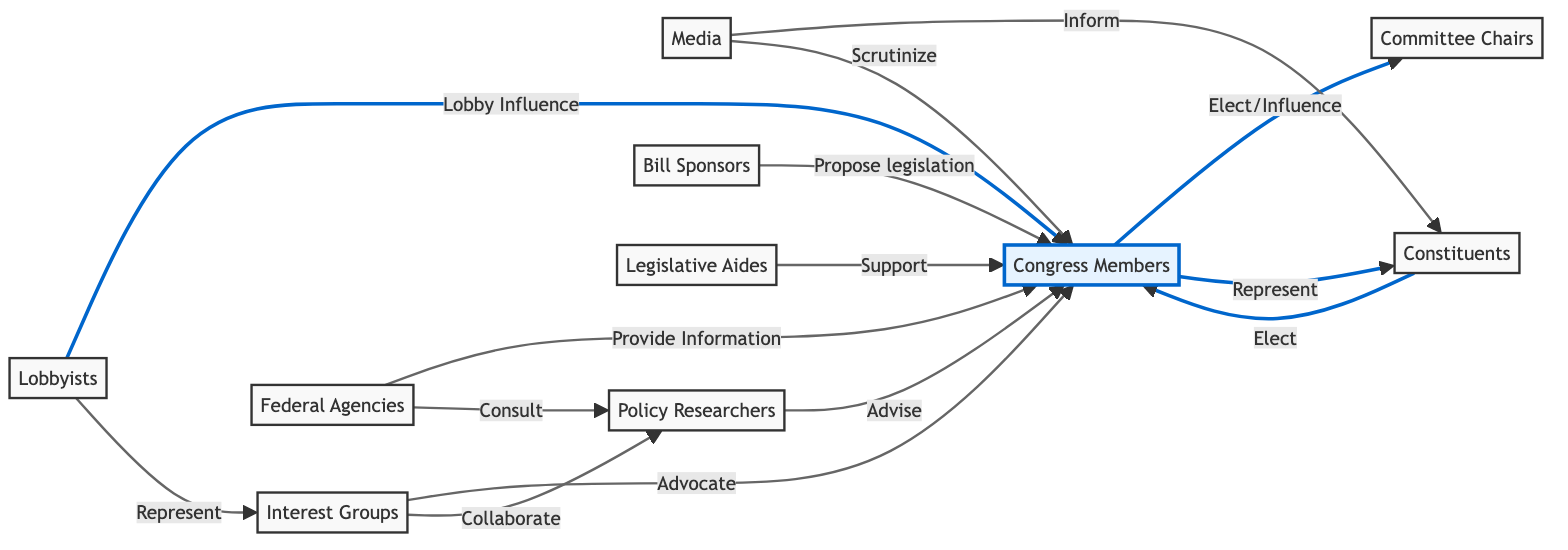What is the total number of nodes in the diagram? The diagram contains 10 nodes, which can be counted directly from the nodes section of the data.
Answer: 10 Which node represents the group that proposes legislation? The node "Bill Sponsors" directly indicates the entity that proposes legislation, as seen in the edges linking "Bill Sponsors" to "Congress Members" with the label "Propose legislation."
Answer: Bill Sponsors How do constituents influence Congress members? Constituents influence Congress members by electing them, as indicated by the directed edge labeled "Elect" from "Constituents" to "Congress Members."
Answer: Elect Which node is connected to "Congress Members" by providing information? "Federal Agencies" is connected to "Congress Members" with the edge labeled "Provide Information," indicating the flow of information from this stakeholder.
Answer: Federal Agencies What is the role of media in relation to Congress members? The media plays the role of scrutinizing Congress members and informing constituents, as shown by two separate directed edges leading from "Media" to "Congress Members" and from "Media" to "Constituents."
Answer: Scrutinize / Inform Which two nodes directly collaborate based on the diagram's connections? "Interest Groups" and "Policy Researchers" collaborate, as indicated by the edge labeled "Collaborate" from "Interest Groups" to "Policy Researchers."
Answer: Interest Groups and Policy Researchers What is the nature of the relationship between lobbyists and interest groups? The relationship is one of representation, as shown by the edge labeled "Represent" leading from "Lobbyists" to "Interest Groups."
Answer: Represent How many connections are there from Congress members to other nodes? Congress members have five outgoing connections: to "Constituents," "Lobbyists," "Committee Chairs," "Federal Agencies," and "Bill Sponsors," totaling five connections.
Answer: 5 What type of influence do lobbyists have over Congress members? Lobbyists exert "Lobby Influence" over Congress members, which is a direct connection reflected in the diagram.
Answer: Lobby Influence 